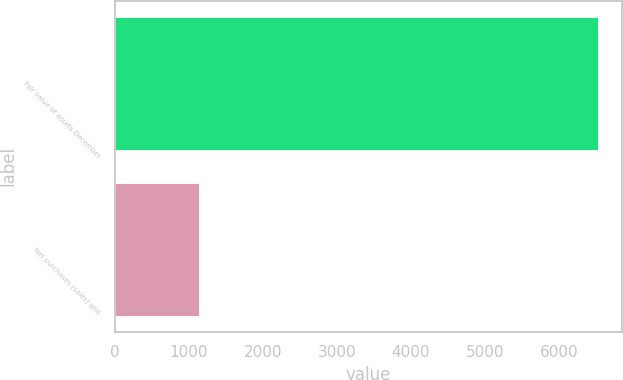Convert chart. <chart><loc_0><loc_0><loc_500><loc_500><bar_chart><fcel>Fair value of assets December<fcel>Net purchases (sales) and<nl><fcel>6531<fcel>1136<nl></chart> 